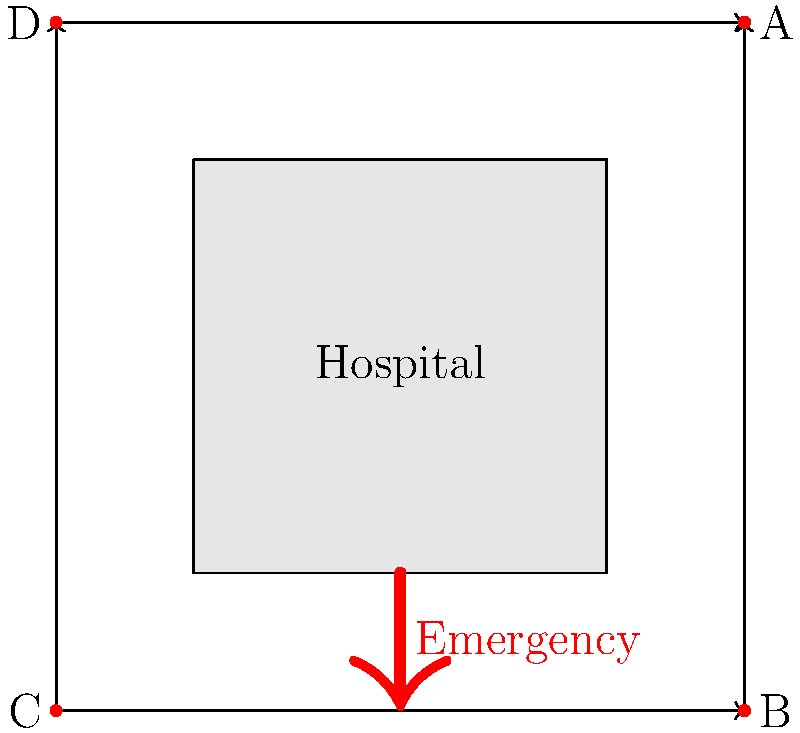As a social worker collaborating with the pediatric nurse to address healthcare disparities, you're asked to provide input on optimizing traffic flow around the children's hospital campus. Given the bird's-eye view map of the hospital, which traffic light sequence would best facilitate emergency vehicle access while maintaining overall traffic flow? Assume each traffic light can be either green (G) or red (R), and the sequence is given in clockwise order starting from point A. To optimize traffic flow around the children's hospital campus while prioritizing emergency vehicle access, we need to consider several factors:

1. Emergency vehicle access: The emergency entrance is located on the south side of the hospital, so we need to ensure easy access from that direction.

2. Overall traffic flow: We want to maintain a steady flow of traffic around the hospital to prevent congestion.

3. Safety: We need to avoid conflicting traffic movements that could lead to accidents.

Let's analyze the optimal traffic light sequence:

1. Point A (top-right): This should be red (R) to allow emergency vehicles to enter from the south and to prevent conflicts with traffic from the east.

2. Point B (bottom-right): This should be green (G) to allow emergency vehicles to approach from the south and to maintain traffic flow from the east.

3. Point C (bottom-left): This should be red (R) to prevent conflicts with emergency vehicles entering from the south and to allow traffic to flow from the east.

4. Point D (top-left): This can be green (G) to maintain overall traffic flow from the north while not interfering with emergency vehicle access.

This sequence (R-G-R-G) allows for:
- Easy access for emergency vehicles from the south
- Continuous traffic flow from east to west and north to south
- Minimized potential conflicts between vehicles

It's important to note that this sequence may need to be adjusted in real-time based on actual traffic conditions and emergency situations. Coordination with traffic engineers and emergency services would be crucial for implementing and fine-tuning this system.
Answer: R-G-R-G 